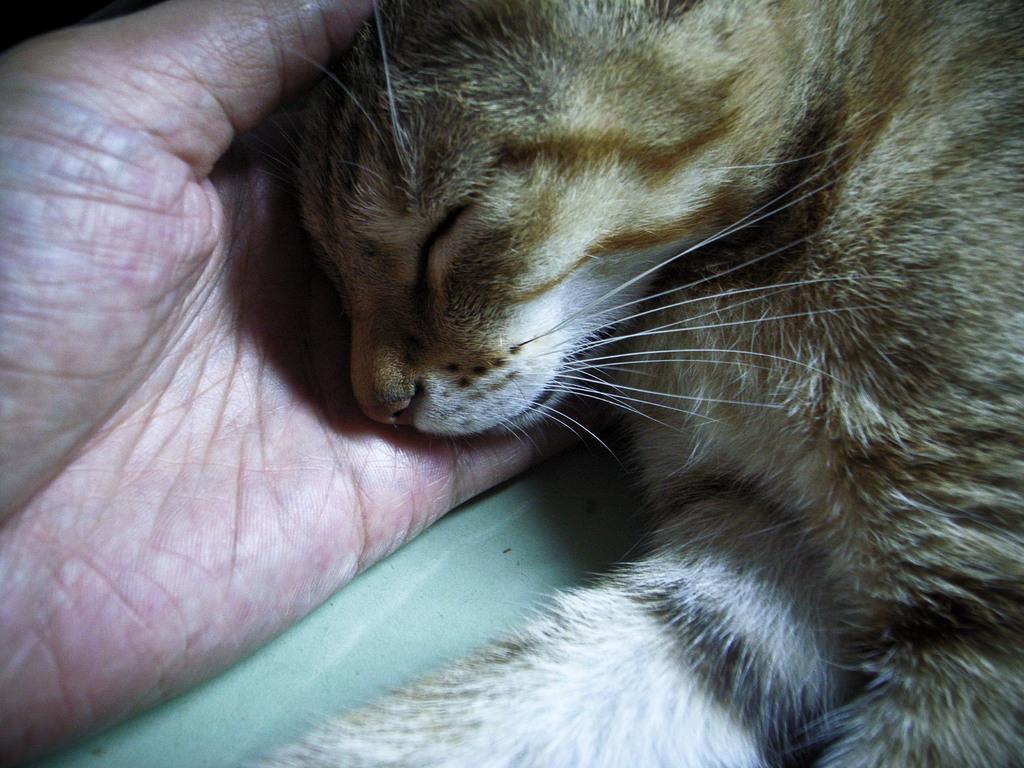How would you summarize this image in a sentence or two? In the picture we can see a lion cub sleeping in the hand of a person. 